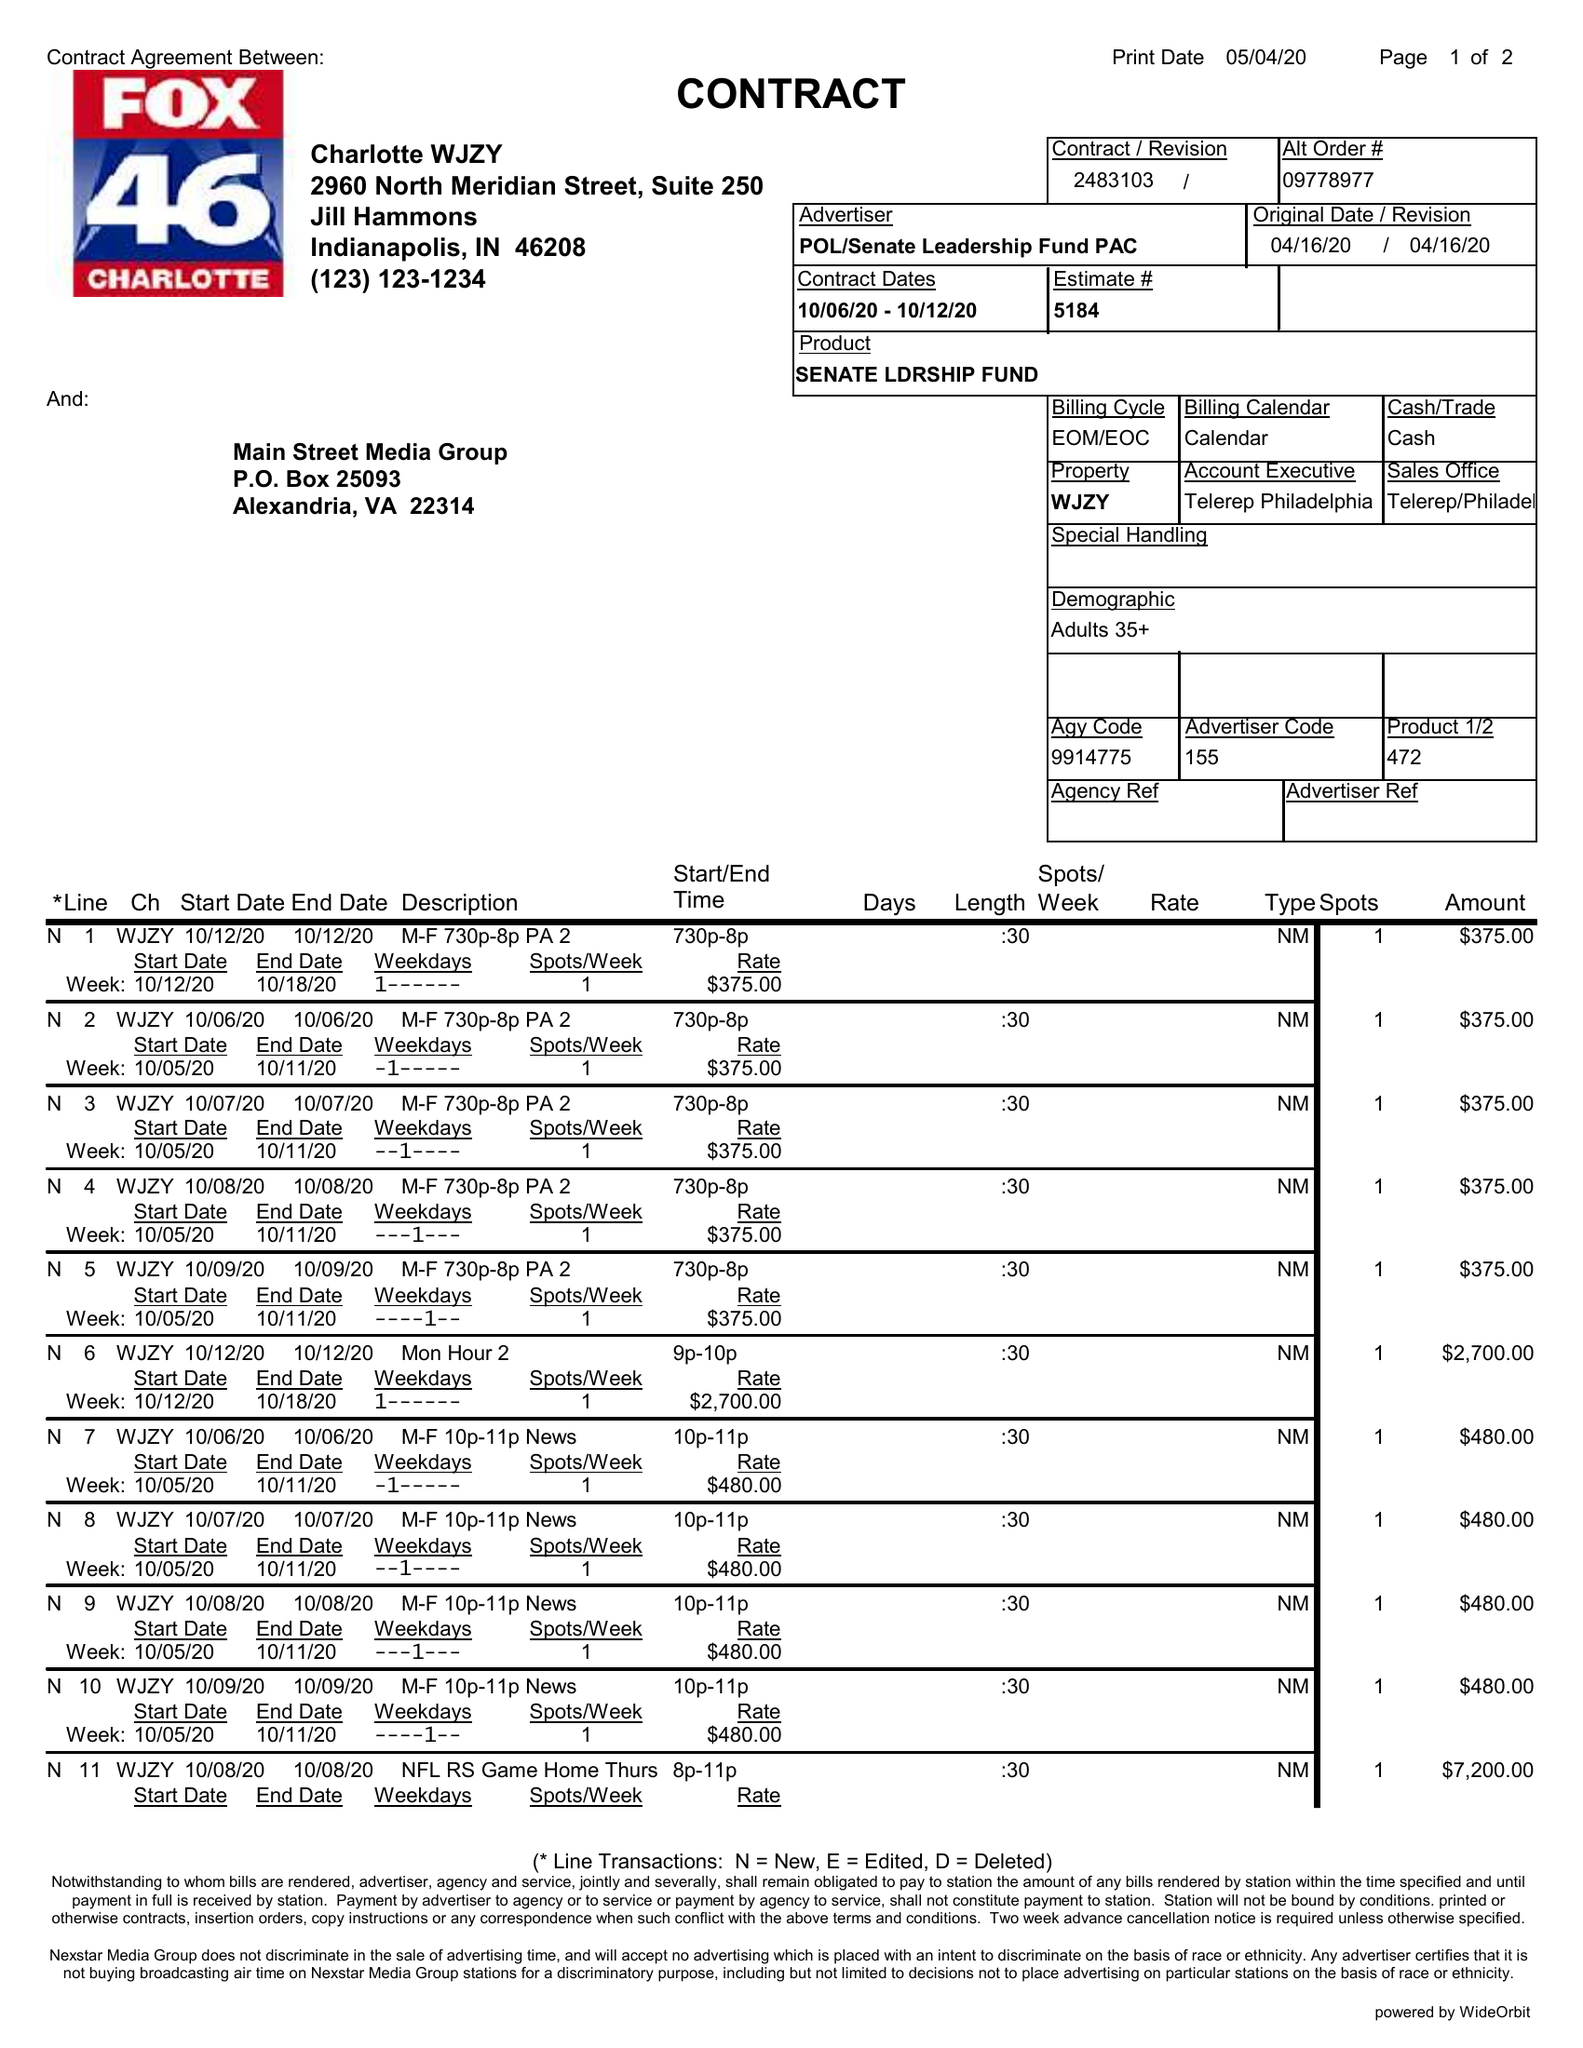What is the value for the flight_to?
Answer the question using a single word or phrase. 10/12/20 